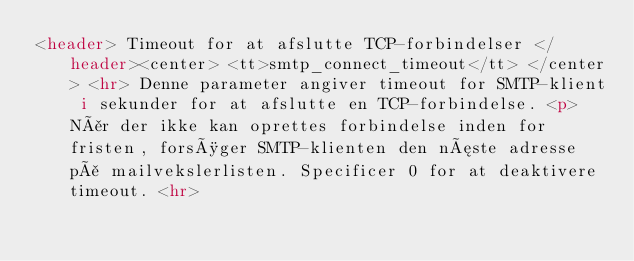<code> <loc_0><loc_0><loc_500><loc_500><_HTML_><header> Timeout for at afslutte TCP-forbindelser </header><center> <tt>smtp_connect_timeout</tt> </center> <hr> Denne parameter angiver timeout for SMTP-klient i sekunder for at afslutte en TCP-forbindelse. <p> Når der ikke kan oprettes forbindelse inden for fristen, forsøger SMTP-klienten den næste adresse på mailvekslerlisten. Specificer 0 for at deaktivere timeout. <hr></code> 